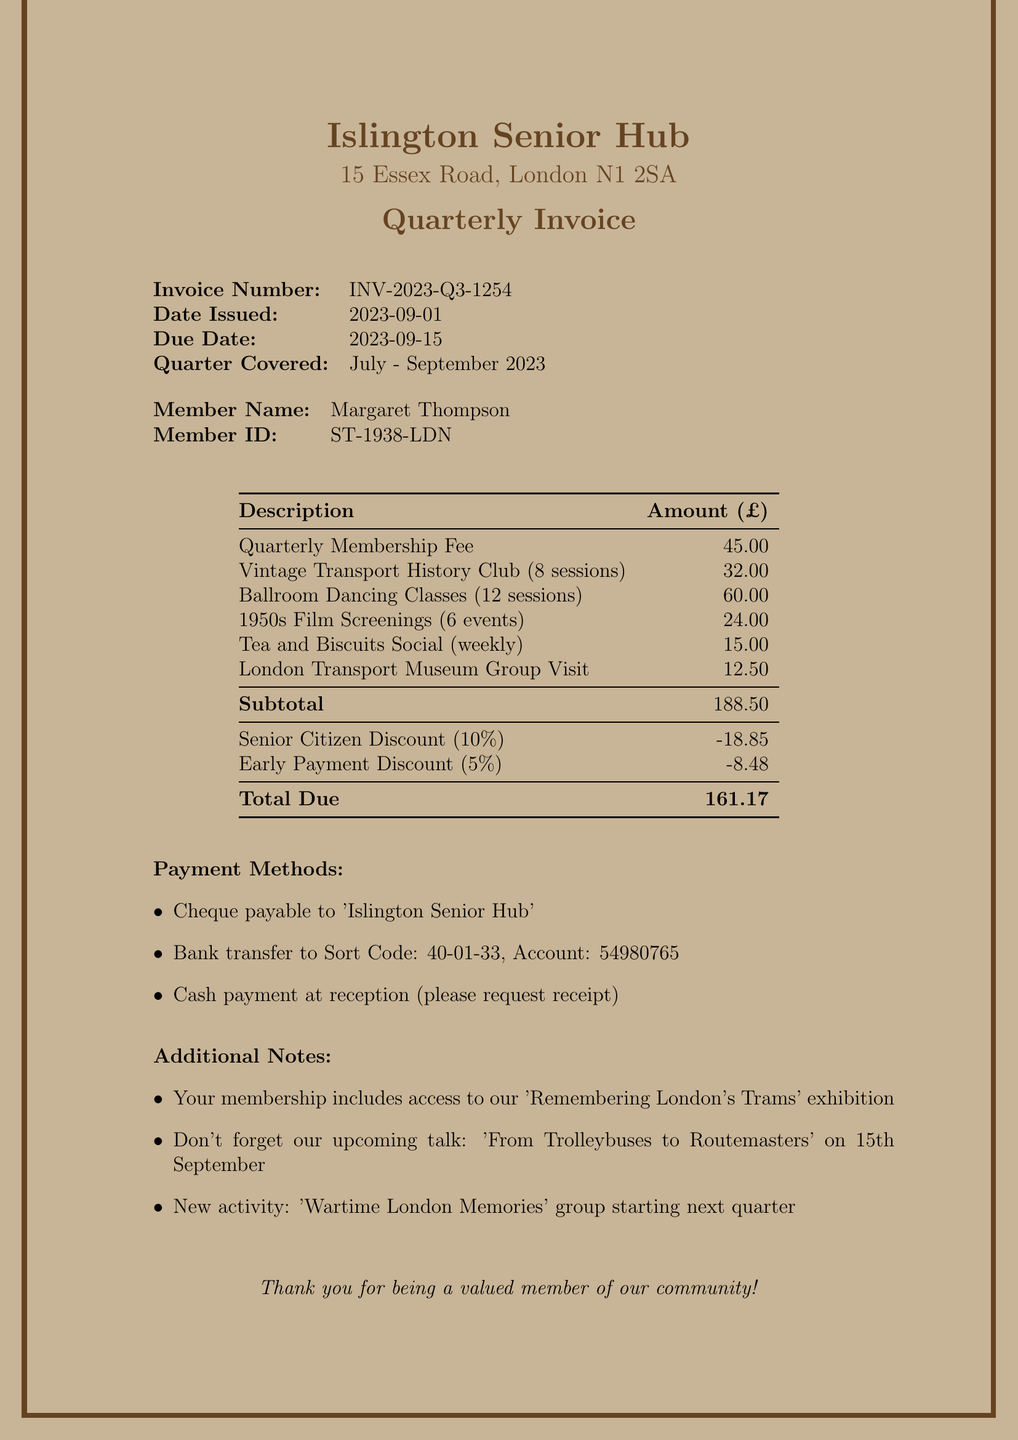What is the invoice number? The invoice number is a specific identifier for the document, stated clearly in the invoice.
Answer: INV-2023-Q3-1254 Who is the member named in this invoice? The member name is indicated right after the invoice details, showing the individual associated with this invoice.
Answer: Margaret Thompson What is the total due amount? The total due amount is summarized at the bottom of the invoice, reflecting the final payment required.
Answer: 161.17 What discounts were applied? The invoice details both discounts provided under the line items section, which impact the total due.
Answer: Senior Citizen Discount (10%), Early Payment Discount (5%) How many activities are listed in the invoice? The number of activities can be determined by counting each line item listed under the activities.
Answer: 6 What is the due date for payment? The due date is stated directly in the invoice to inform the member when payment is required.
Answer: 2023-09-15 What activity has the highest fee? The description of each activity notes the fee, allowing for comparison to find the highest.
Answer: Ballroom Dancing Classes (12 sessions) What method of payment is NOT mentioned in the invoice? This question requires understanding the list of payment methods provided and identifying any missing options.
Answer: Credit card 